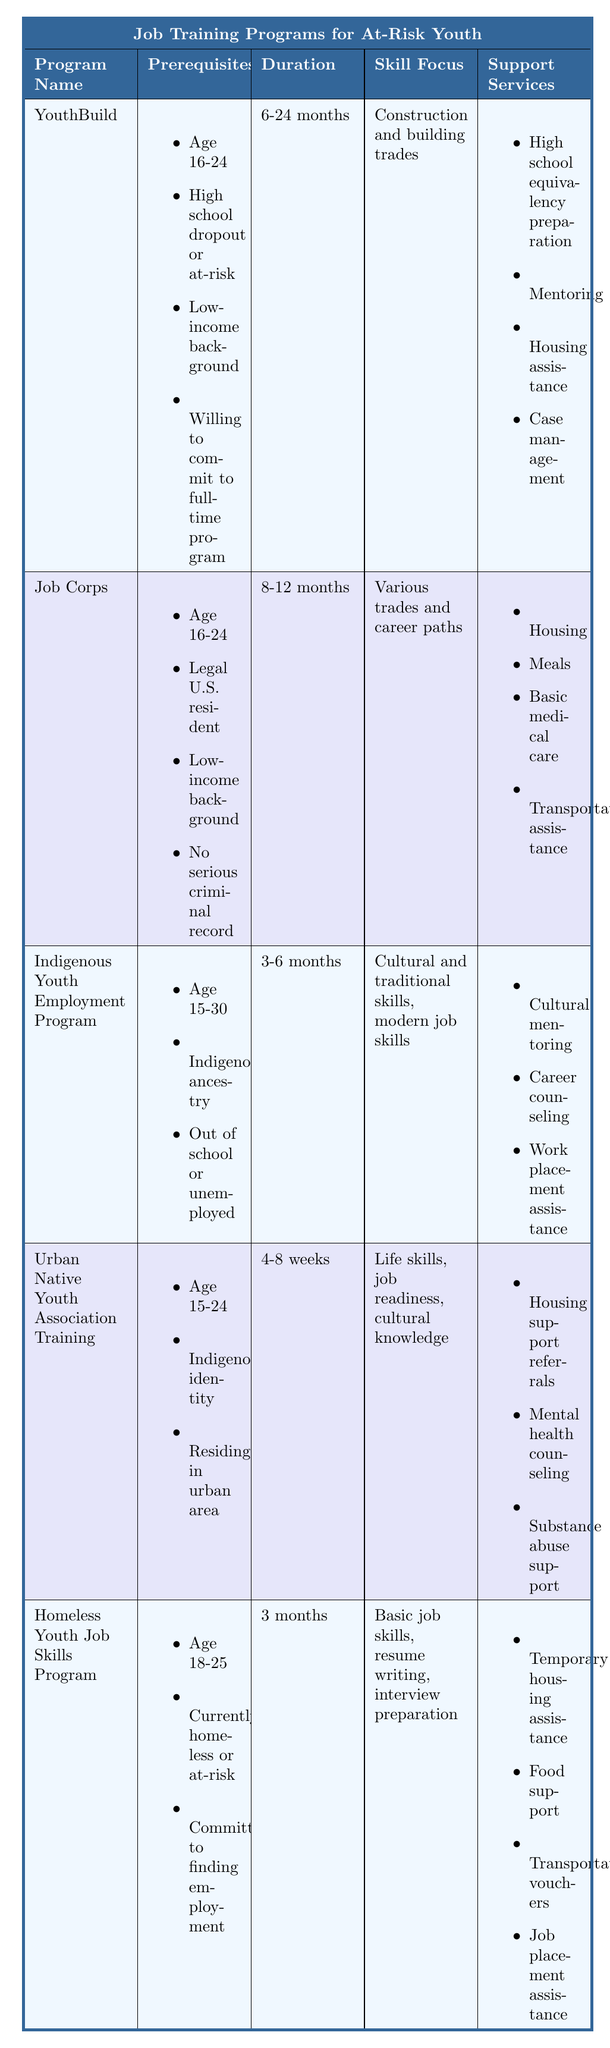What is the duration of the Job Corps program? The Job Corps program's duration is stated directly in the table, which shows it lasts for 8-12 months.
Answer: 8-12 months Which programs require being between the ages of 18 and 25? From the table, we look at the age requirements for each program. Only the Homeless Youth Job Skills Program lists the age range of 18-25.
Answer: Homeless Youth Job Skills Program Is cultural mentoring offered in the YouthBuild program? The table lists support services for the YouthBuild program, which does not include cultural mentoring. Therefore, the answer is no.
Answer: No How many programs have a duration of less than six months? In the table, the durations of each program are noted. The Indigenous Youth Employment Program has a duration of 3-6 months, and the Urban Native Youth Association Training lasts 4-8 weeks. Thus, there are two programs with a maximum duration of under six months.
Answer: 2 What is the skill focus of the Urban Native Youth Association Training program? By referring to the table, we see that the Urban Native Youth Association Training focuses on life skills, job readiness, and cultural knowledge.
Answer: Life skills, job readiness, cultural knowledge Which program has the shortest duration and what is it? The table shows the various program durations. The Urban Native Youth Association Training has a minimum duration of 4-8 weeks, making it the shortest program.
Answer: Urban Native Youth Association Training, 4-8 weeks Do all programs require a low-income background? Reviewing the prerequisites in the table, not all programs specify a low-income background as a requirement. For instance, the Urban Native Youth Association Training does not mention this factor. Therefore, the answer is no.
Answer: No How many of the programs focus on construction and building trades? The table details that only one program, YouthBuild, has a skill focus specifically on construction and building trades.
Answer: 1 What types of support services does the Homeless Youth Job Skills Program include? According to the table, the Homeless Youth Job Skills Program offers various support services, including temporary housing assistance, food support, transportation vouchers, and job placement assistance.
Answer: Temporary housing assistance, food support, transportation vouchers, job placement assistance 